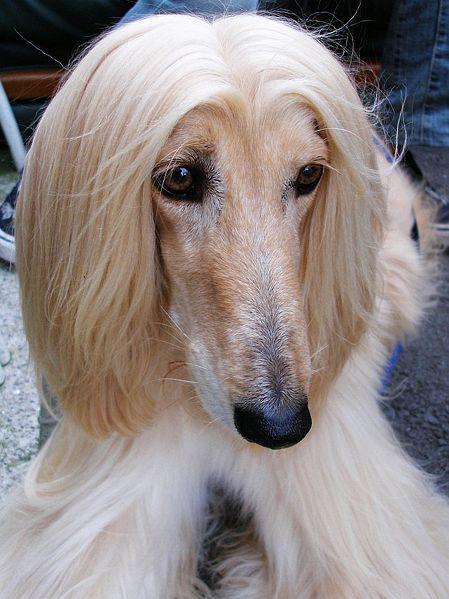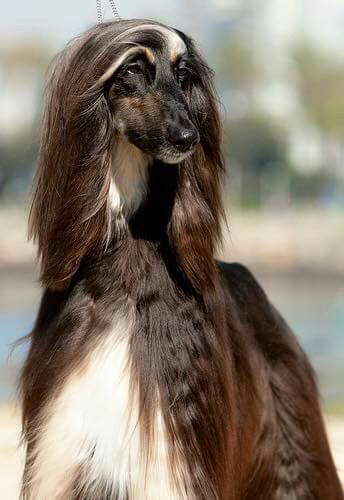The first image is the image on the left, the second image is the image on the right. Assess this claim about the two images: "The dog in the image in the left has its mouth open.". Correct or not? Answer yes or no. No. 